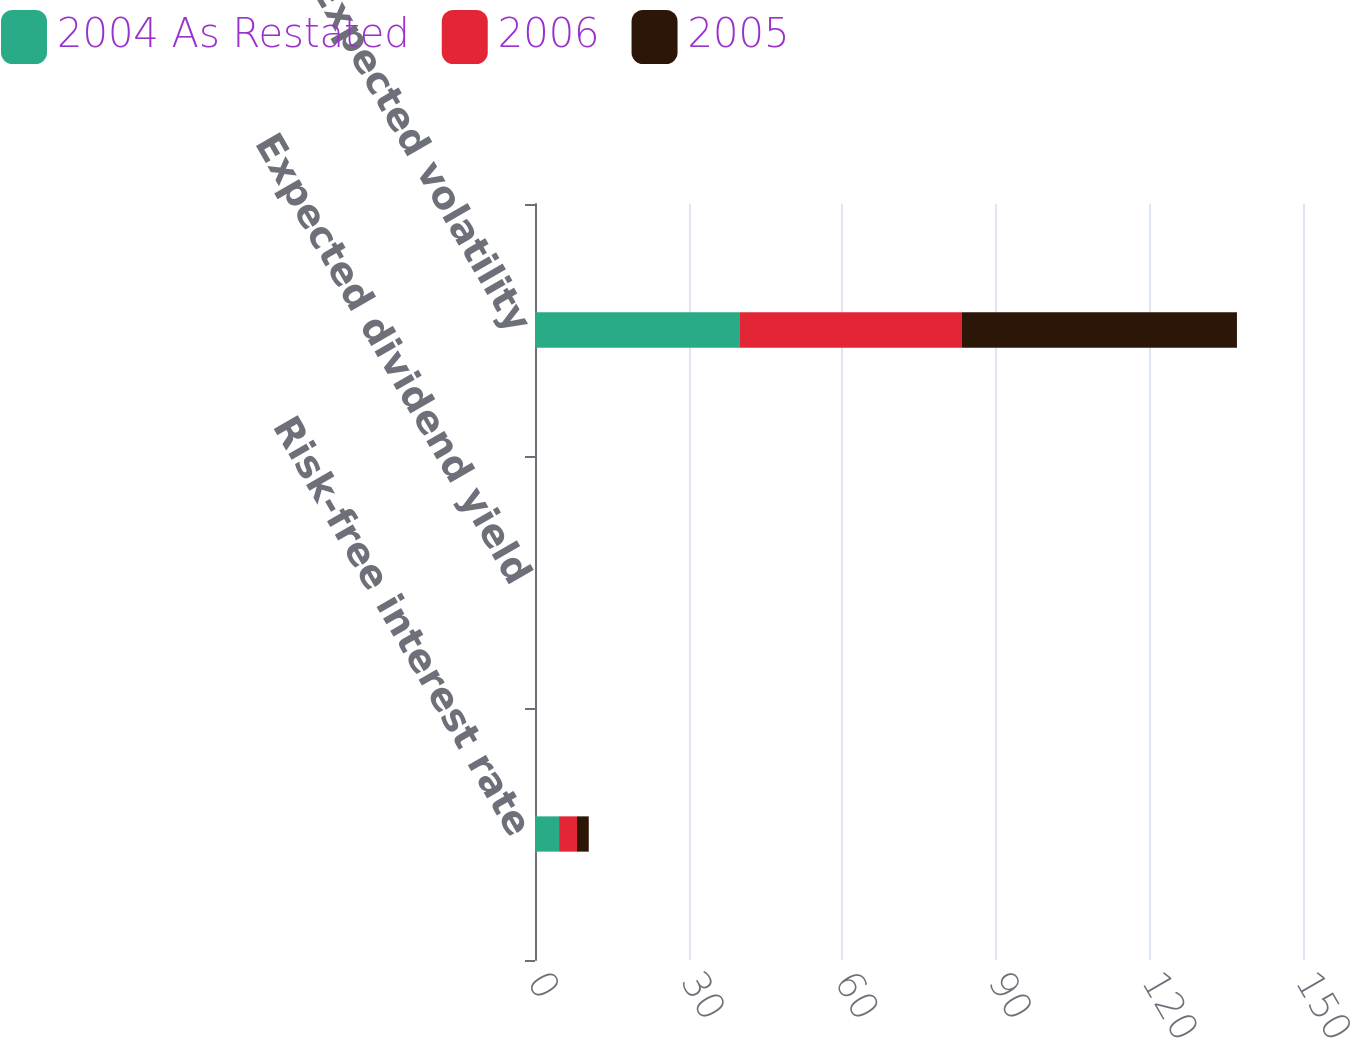<chart> <loc_0><loc_0><loc_500><loc_500><stacked_bar_chart><ecel><fcel>Risk-free interest rate<fcel>Expected dividend yield<fcel>Expected volatility<nl><fcel>2004 As Restated<fcel>4.7<fcel>0<fcel>39.9<nl><fcel>2006<fcel>3.5<fcel>0<fcel>43.5<nl><fcel>2005<fcel>2.3<fcel>0<fcel>53.7<nl></chart> 